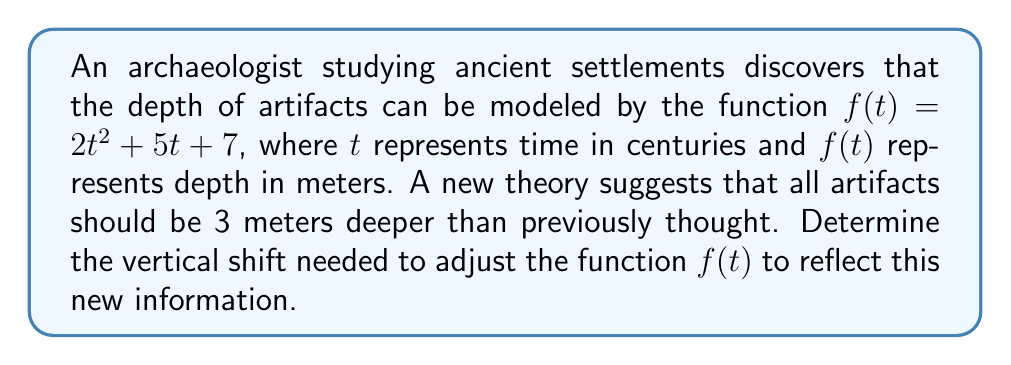Show me your answer to this math problem. To solve this problem, we need to understand vertical shifts in functions:

1) A vertical shift changes the y-intercept of a function without affecting its shape.

2) To shift a function vertically, we add or subtract a constant to the entire function.

3) The general form of a vertical shift is:
   $g(t) = f(t) + k$, where $k$ is the shift amount.

4) If $k$ is positive, the function shifts up. If $k$ is negative, the function shifts down.

In this case:
- The original function is $f(t) = 2t^2 + 5t + 7$
- We need to shift all artifacts 3 meters deeper
- Deeper means increasing the y-value (depth)

Therefore, we need to add 3 to the function:

$g(t) = f(t) + 3 = (2t^2 + 5t + 7) + 3 = 2t^2 + 5t + 10$

The vertical shift is +3 meters upward in the coordinate system (which represents a deeper position for the artifacts).
Answer: The vertical shift needed is +3 meters. 